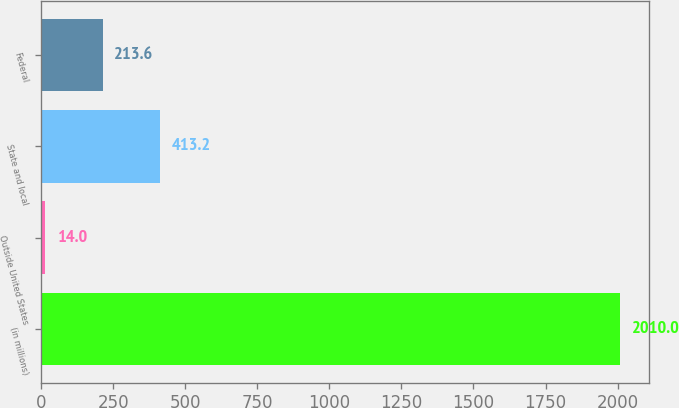Convert chart. <chart><loc_0><loc_0><loc_500><loc_500><bar_chart><fcel>(in millions)<fcel>Outside United States<fcel>State and local<fcel>Federal<nl><fcel>2010<fcel>14<fcel>413.2<fcel>213.6<nl></chart> 